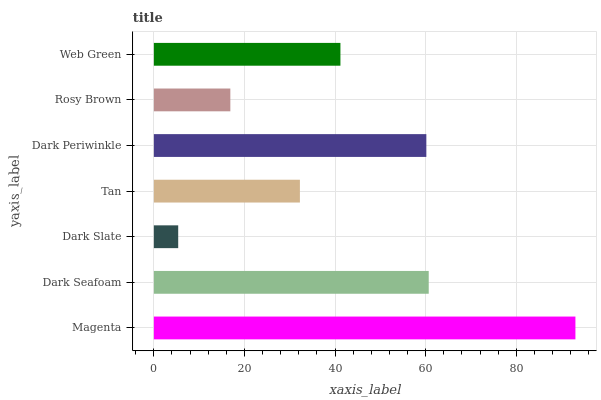Is Dark Slate the minimum?
Answer yes or no. Yes. Is Magenta the maximum?
Answer yes or no. Yes. Is Dark Seafoam the minimum?
Answer yes or no. No. Is Dark Seafoam the maximum?
Answer yes or no. No. Is Magenta greater than Dark Seafoam?
Answer yes or no. Yes. Is Dark Seafoam less than Magenta?
Answer yes or no. Yes. Is Dark Seafoam greater than Magenta?
Answer yes or no. No. Is Magenta less than Dark Seafoam?
Answer yes or no. No. Is Web Green the high median?
Answer yes or no. Yes. Is Web Green the low median?
Answer yes or no. Yes. Is Rosy Brown the high median?
Answer yes or no. No. Is Dark Periwinkle the low median?
Answer yes or no. No. 